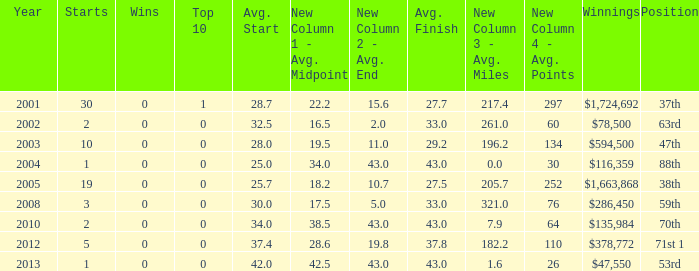How many wins for average start less than 25? 0.0. 